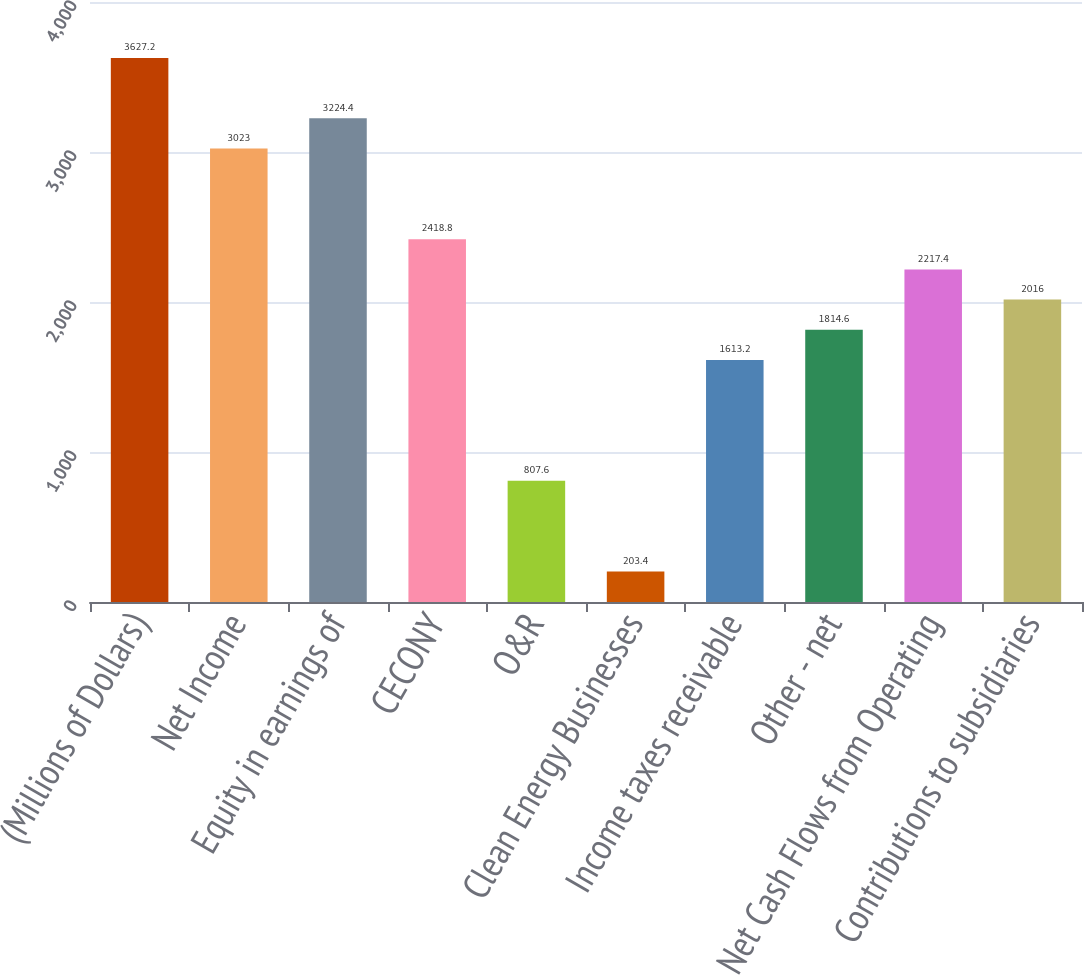<chart> <loc_0><loc_0><loc_500><loc_500><bar_chart><fcel>(Millions of Dollars)<fcel>Net Income<fcel>Equity in earnings of<fcel>CECONY<fcel>O&R<fcel>Clean Energy Businesses<fcel>Income taxes receivable<fcel>Other - net<fcel>Net Cash Flows from Operating<fcel>Contributions to subsidiaries<nl><fcel>3627.2<fcel>3023<fcel>3224.4<fcel>2418.8<fcel>807.6<fcel>203.4<fcel>1613.2<fcel>1814.6<fcel>2217.4<fcel>2016<nl></chart> 